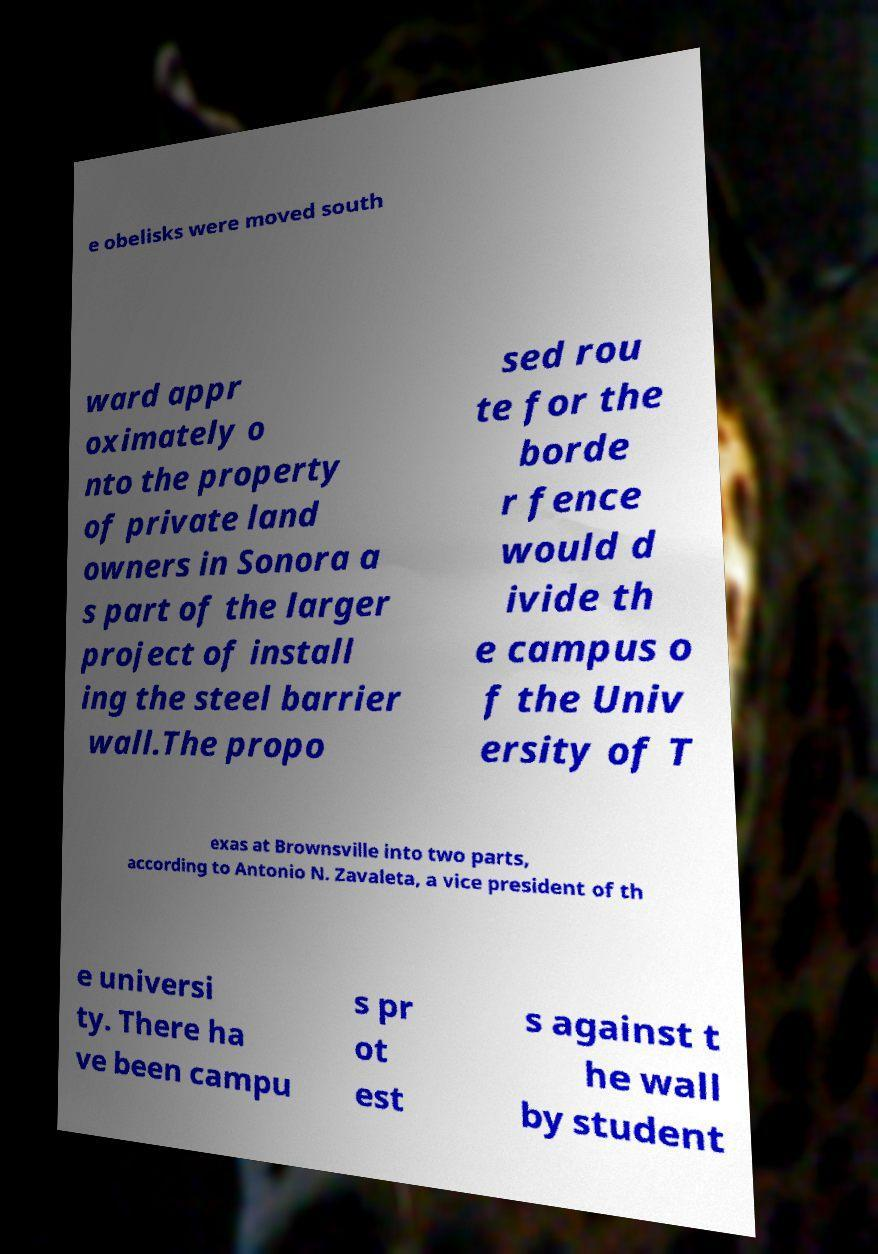I need the written content from this picture converted into text. Can you do that? e obelisks were moved south ward appr oximately o nto the property of private land owners in Sonora a s part of the larger project of install ing the steel barrier wall.The propo sed rou te for the borde r fence would d ivide th e campus o f the Univ ersity of T exas at Brownsville into two parts, according to Antonio N. Zavaleta, a vice president of th e universi ty. There ha ve been campu s pr ot est s against t he wall by student 